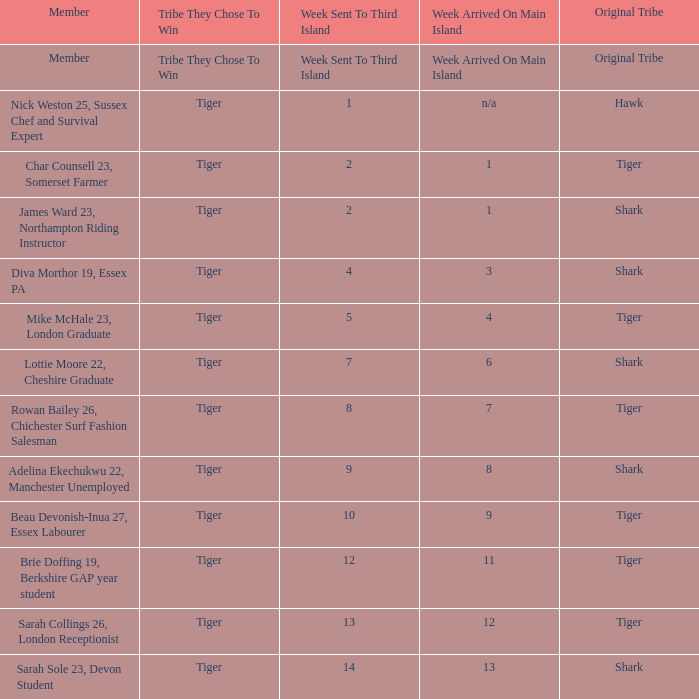How many members arrived on the main island in week 4? 1.0. 